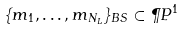<formula> <loc_0><loc_0><loc_500><loc_500>\{ m _ { 1 } , \dots , m _ { N _ { L } } \} _ { B S } \subset \P P ^ { 1 }</formula> 